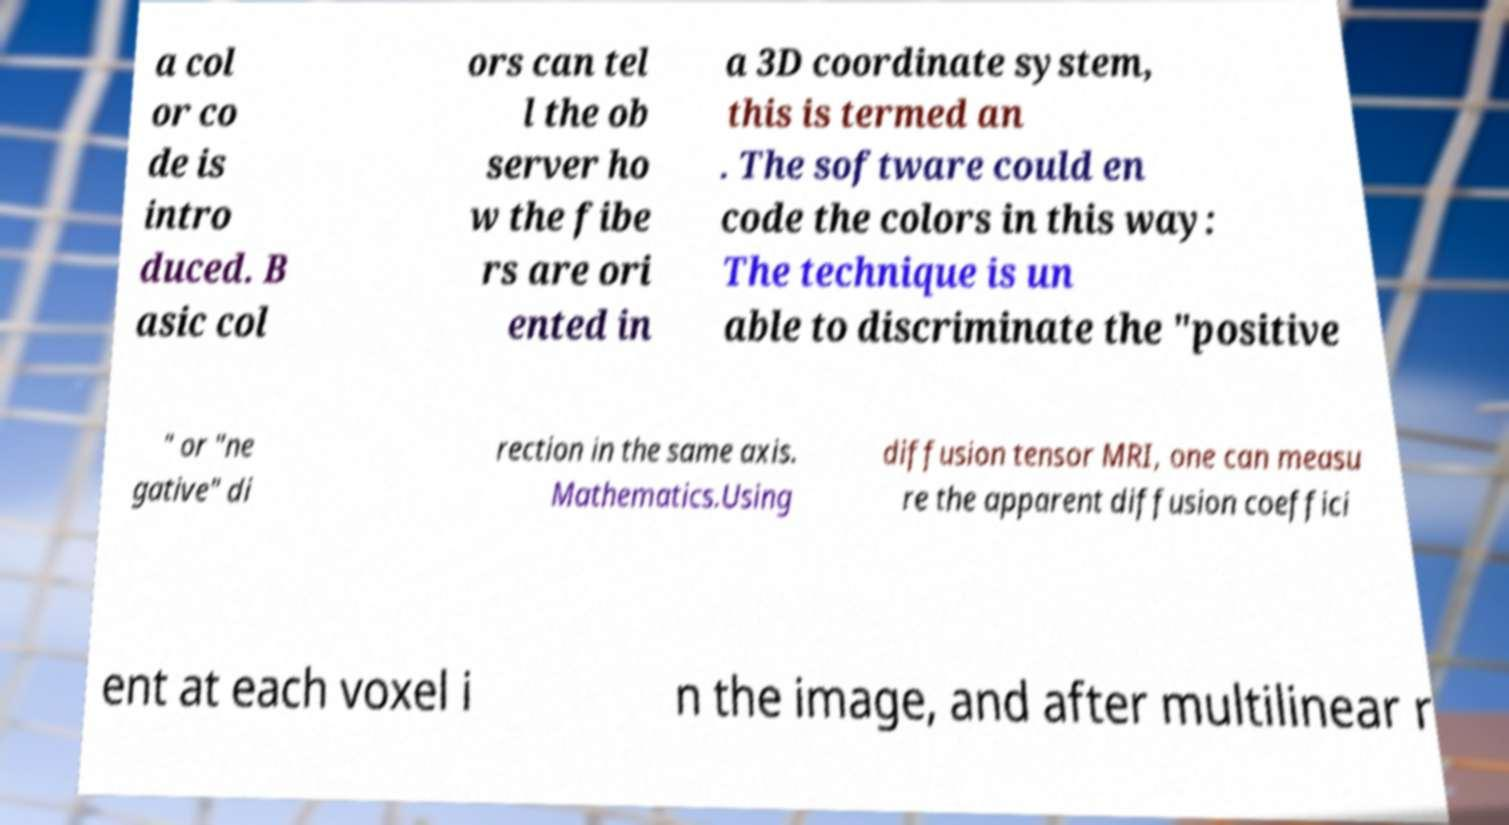Could you extract and type out the text from this image? a col or co de is intro duced. B asic col ors can tel l the ob server ho w the fibe rs are ori ented in a 3D coordinate system, this is termed an . The software could en code the colors in this way: The technique is un able to discriminate the "positive " or "ne gative" di rection in the same axis. Mathematics.Using diffusion tensor MRI, one can measu re the apparent diffusion coeffici ent at each voxel i n the image, and after multilinear r 